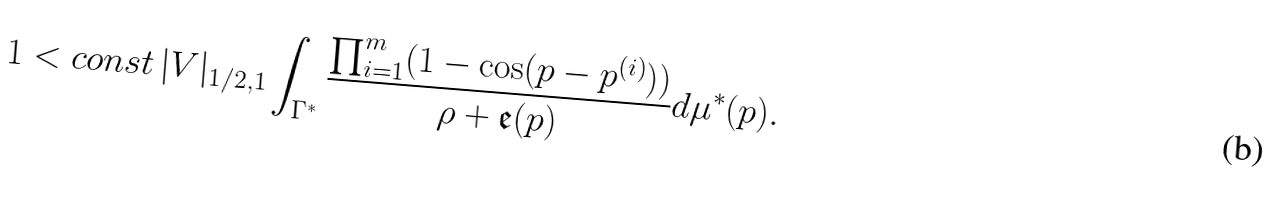Convert formula to latex. <formula><loc_0><loc_0><loc_500><loc_500>1 < c o n s t \, | V | _ { 1 / 2 , 1 } \int _ { \Gamma ^ { \ast } } \frac { \prod _ { i = 1 } ^ { m } ( 1 - \cos ( p - p ^ { ( i ) } ) ) } { \rho + \mathfrak { e } ( p ) } d \mu ^ { \ast } ( p ) .</formula> 